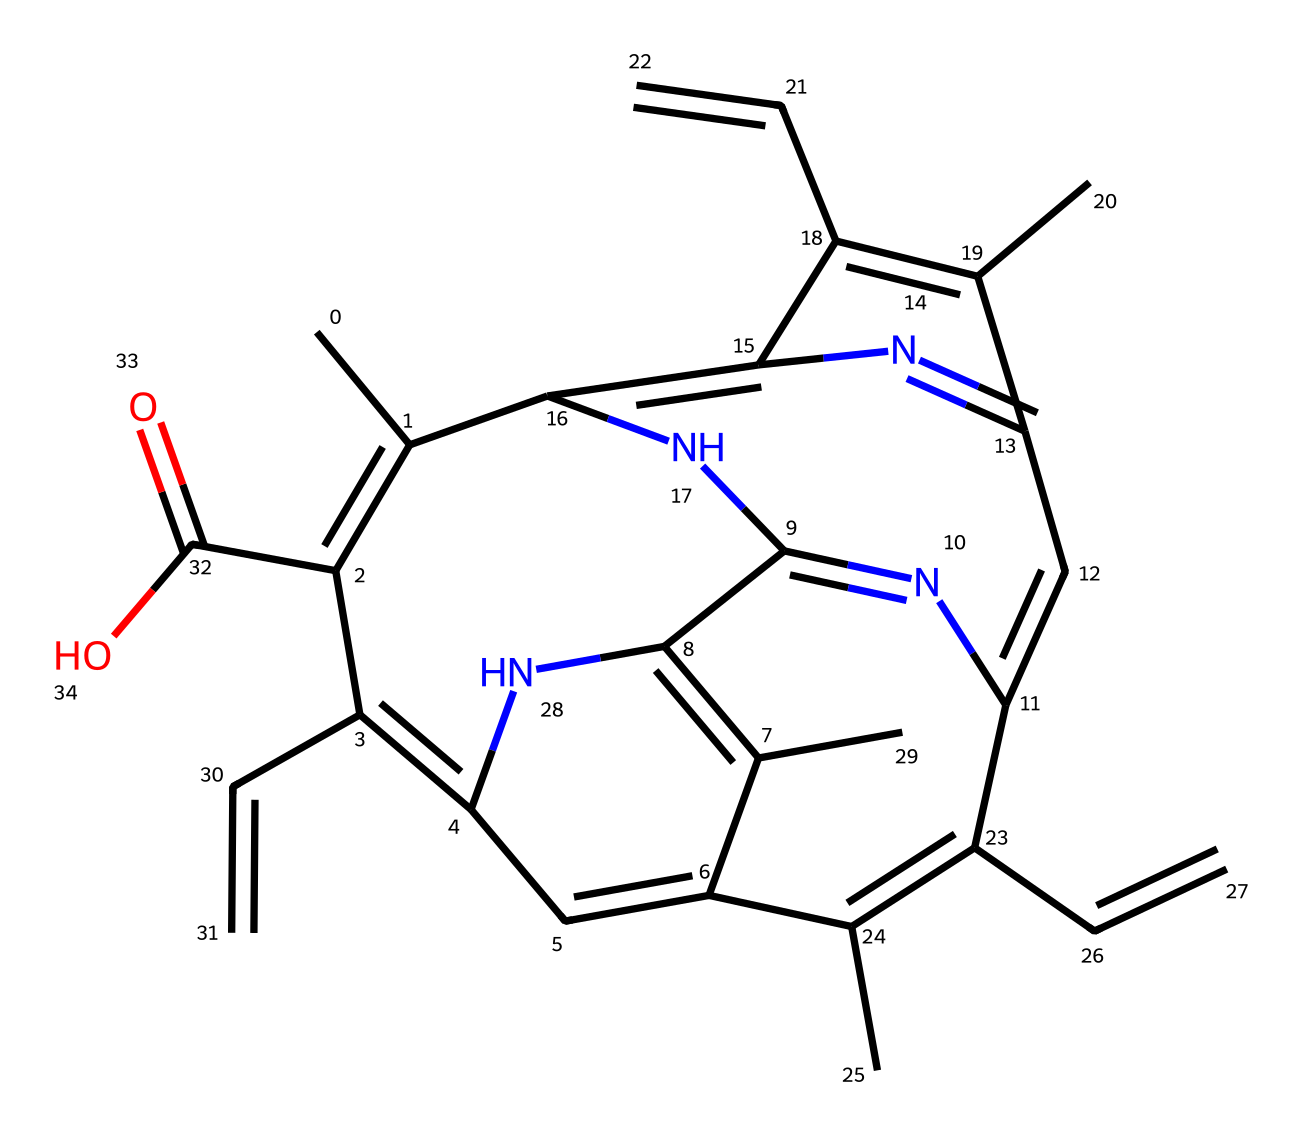How many nitrogen atoms are present in this chemical structure? By analyzing the SMILES representation, we count the occurrence of the nitrogen symbol (N). In the given structure, there are five instances of nitrogen.
Answer: five What is the overall molecular formula of this coordination compound? To determine the molecular formula, we can calculate the number of carbon, hydrogen, nitrogen, and oxygen atoms present in the SMILES notation using the appropriate symbols (C, H, N, O). The analysis reveals that the molecular formula is C20H20N4O2.
Answer: C20H20N4O2 Which elements are present in this compound? By examining the SMILES structure, we identify the symbols: C for carbon, H for hydrogen, N for nitrogen, and O for oxygen. This indicates the presence of these four elements.
Answer: carbon, hydrogen, nitrogen, oxygen What kind of coordination complex is represented by this chemical structure? This compound exhibits coordination characteristics due to the presence of metal ion coordination sites (like nitrogen atoms), typically associated with heme groups that coordinate to iron in hemoglobin.
Answer: heme complex What role does the nitrogen atom play in this chemical structure? The nitrogen atoms in this coordination compound are likely involved in forming coordination bonds with a metal ion (iron), which is essential for the binding of oxygen in hemoglobin.
Answer: coordination bonds What is the significance of the carboxylic acid group in the structure? The carboxylic acid group (–COOH) in the structure can interact with the environment and contribute to the compound's overall pH and solubility properties, which affect hemoglobin function in buffering oxygen transport.
Answer: pH and solubility effects 